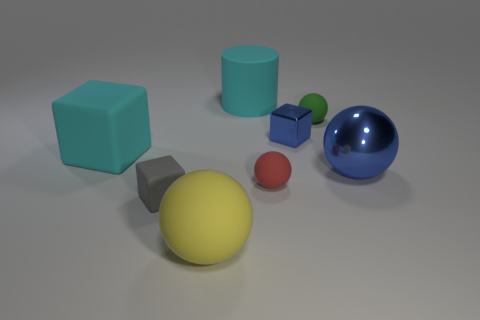Are there any geometric patterns or alignments among these objects? There doesn't seem to be a deliberate geometric pattern or precise alignment to these objects, but there's a visible clustering of objects at the center. They are spread across the surface seemingly randomly, perhaps to display a variety of geometric shapes and colors. 